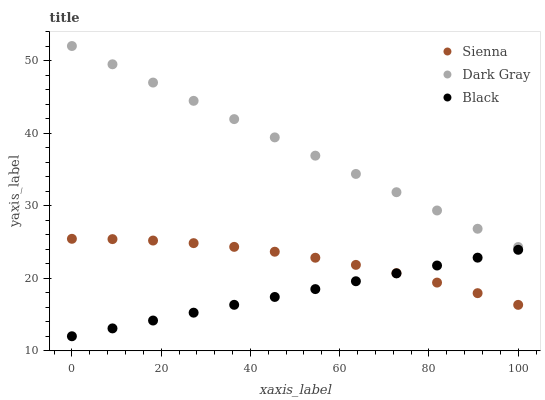Does Black have the minimum area under the curve?
Answer yes or no. Yes. Does Dark Gray have the maximum area under the curve?
Answer yes or no. Yes. Does Dark Gray have the minimum area under the curve?
Answer yes or no. No. Does Black have the maximum area under the curve?
Answer yes or no. No. Is Dark Gray the smoothest?
Answer yes or no. Yes. Is Sienna the roughest?
Answer yes or no. Yes. Is Black the smoothest?
Answer yes or no. No. Is Black the roughest?
Answer yes or no. No. Does Black have the lowest value?
Answer yes or no. Yes. Does Dark Gray have the lowest value?
Answer yes or no. No. Does Dark Gray have the highest value?
Answer yes or no. Yes. Does Black have the highest value?
Answer yes or no. No. Is Sienna less than Dark Gray?
Answer yes or no. Yes. Is Dark Gray greater than Black?
Answer yes or no. Yes. Does Black intersect Sienna?
Answer yes or no. Yes. Is Black less than Sienna?
Answer yes or no. No. Is Black greater than Sienna?
Answer yes or no. No. Does Sienna intersect Dark Gray?
Answer yes or no. No. 